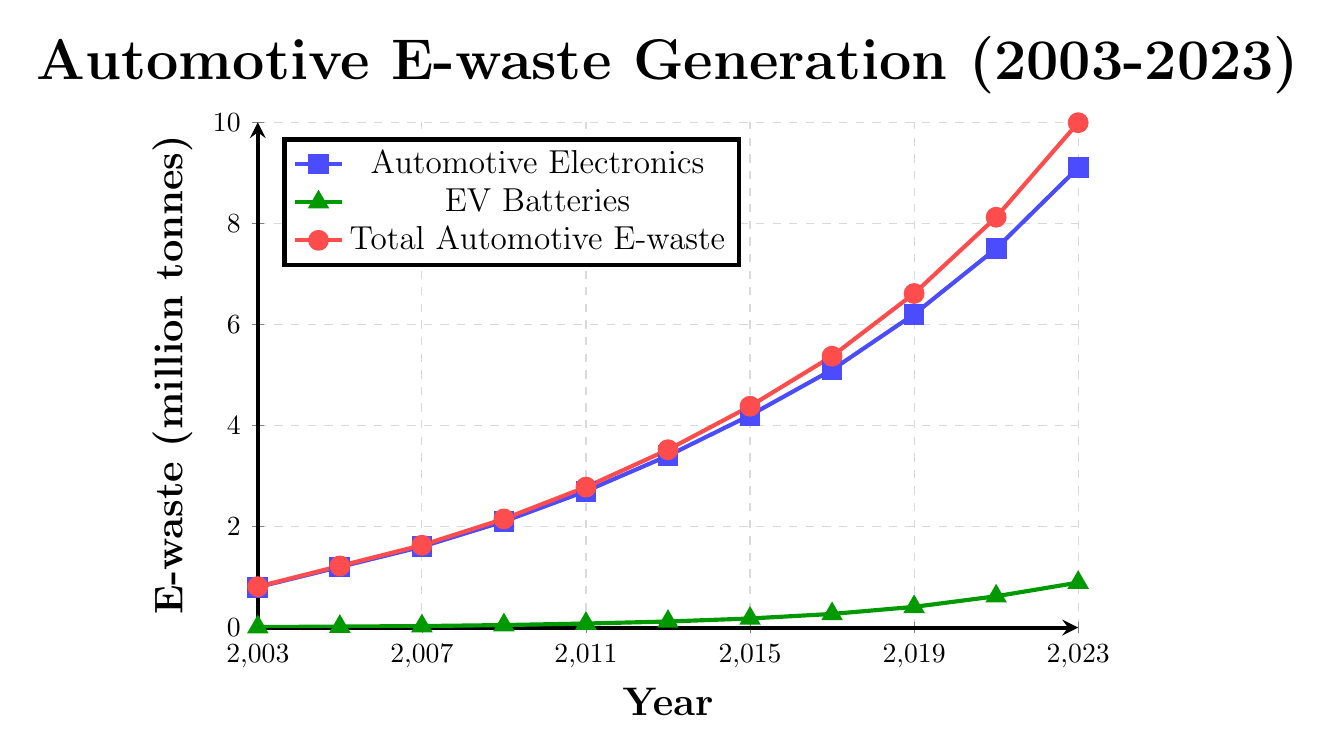What's the trend in Automotive Electronics E-waste over the 20 years? From the figure, we can see that the amount of Automotive Electronics E-waste has increased consistently over the 20-year period. It started at 0.8 million tonnes in 2003 and reached 9.1 million tonnes in 2023.
Answer: Increasing trend How much total Automotive E-waste was generated in 2013? Locate the point corresponding to the year 2013 in the Total Automotive E-waste line (red line). The amount of Total Automotive E-waste in 2013 is 3.52 million tonnes.
Answer: 3.52 million tonnes Which year saw the largest absolute increase in Total Automotive E-waste from the previous year? By examining the differences between consecutive data points on the red line, we compare the increase: (2005 - 2003 = 0.41), (2007 - 2005 = 0.41), (2009 - 2007 = 0.52), (2011 - 2009 = 0.63), (2013 - 2011 = 0.74), (2015 - 2013 = 0.86), (2017 - 2015 = 0.99), (2019 - 2017 = 1.24), (2021 - 2019 = 1.51), (2023 - 2021 = 1.87). The largest increase occurred between 2021 and 2023.
Answer: 2023 What is the difference between the E-waste generated from Automotive Electronics and EV Batteries in 2023? The amount of E-waste generated from Automotive Electronics in 2023 is 9.1 million tonnes, and from EV Batteries is 0.89 million tonnes. The difference is 9.1 - 0.89 = 8.21 million tonnes.
Answer: 8.21 million tonnes How does the E-waste generated from EV Batteries in 2015 compare to that in 2003? From the figure, the E-waste from EV Batteries in 2015 is marked at 0.18 million tonnes, and in 2003 it’s at 0.01 million tonnes. Comparing these values shows an increase.
Answer: Increased What is the average growth rate of E-waste generated from Automotive Electronics from 2003 to 2023? The E-waste for Automotive Electronics increased from 0.8 million tonnes in 2003 to 9.1 million tonnes in 2023. The growth over 20 years is 9.1 - 0.8 = 8.3 million tonnes. Average annual growth rate = 8.3 / 20 ≈ 0.415 million tonnes per year.
Answer: ≈ 0.415 million tonnes per year Which year had the highest total Automotive E-waste among the recorded years? By observing the highest point on the red line, we see the highest value is in 2023, with 9.99 million tonnes.
Answer: 2023 How much more E-waste is generated in 2023 from EV Batteries compared to 2003? The E-waste from EV Batteries in 2023 is 0.89 million tonnes, and in 2003 it is 0.01 million tonnes. The difference is 0.89 - 0.01 = 0.88 million tonnes.
Answer: 0.88 million tonnes What is the combined E-waste generated by Automotive Electronics and EV Batteries in 2017? From the figure, in 2017, Automotive Electronics generated 5.1 million tonnes and EV Batteries generated 0.27 million tonnes. The combined E-waste is 5.1 + 0.27 = 5.37 million tonnes.
Answer: 5.37 million tonnes 